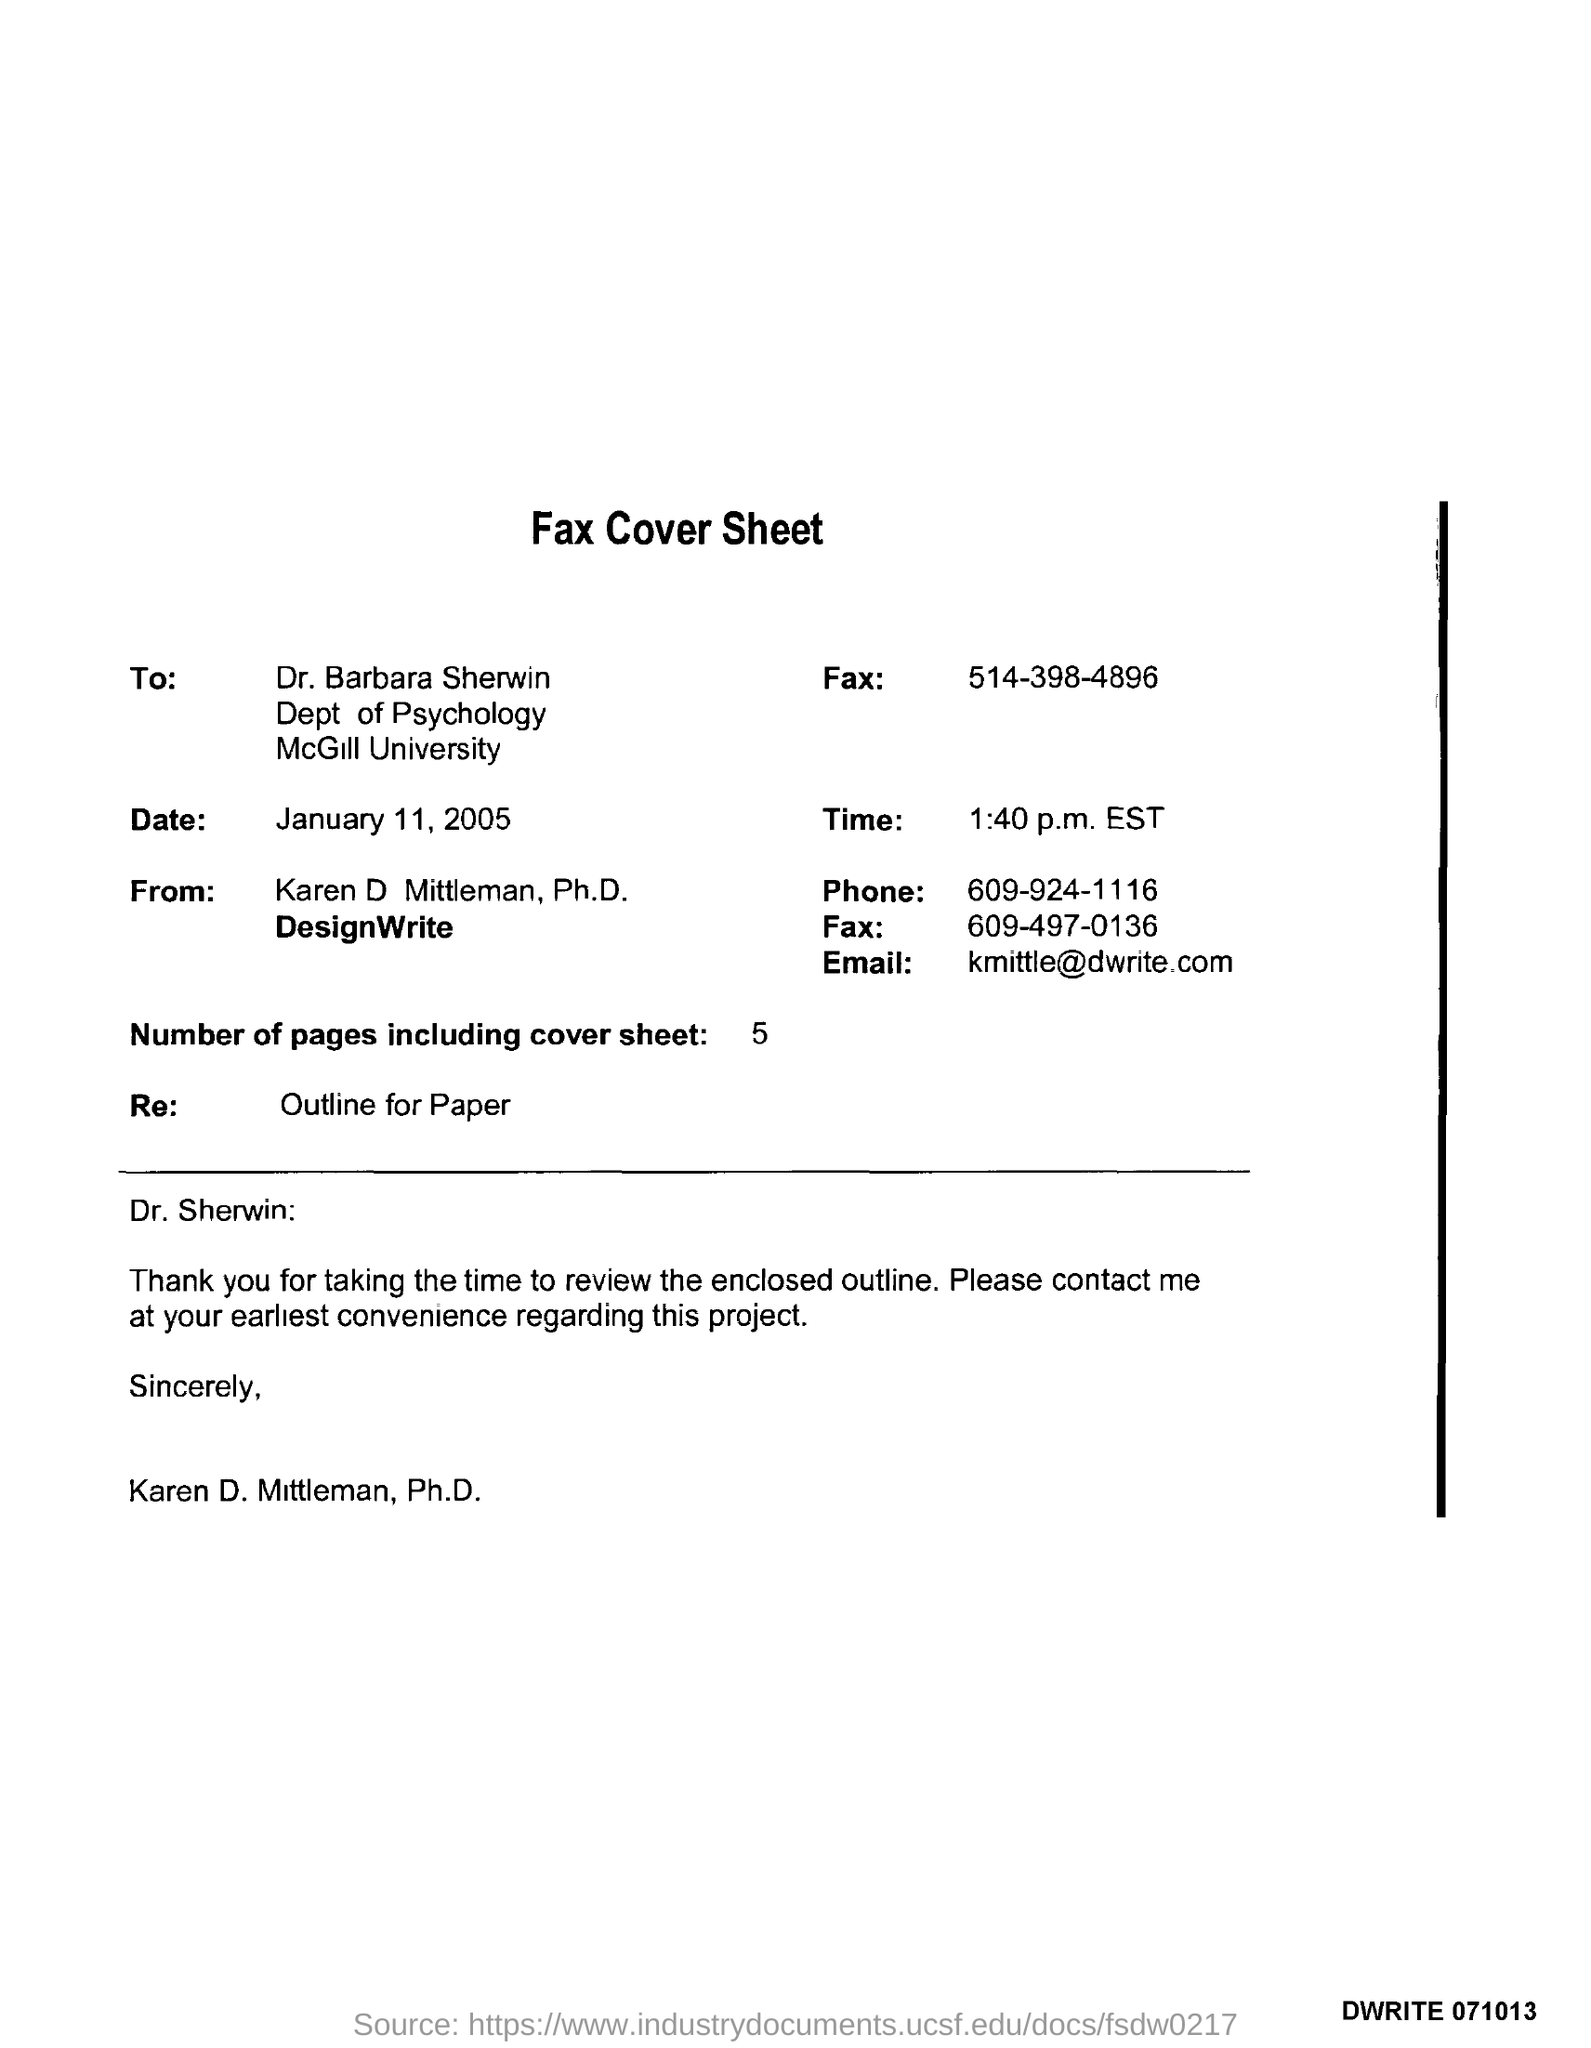Who is the receiver of the Fax?
Your response must be concise. Dr. Barbara Sherwin. In which University Dr. Barbara Sherwin works?
Your answer should be compact. McGill University. What is the  Fax No of Dr. Barbara Sherwin?
Provide a short and direct response. 514-398-4896. What is the date mentioned in the fax cover sheet?
Give a very brief answer. January 11, 2005. What is the time mentioned in fax cover sheet?
Your answer should be very brief. 1:40 p.m. EST. How many pages are there in the fax including cover sheet?
Your answer should be compact. 5. What is the Email id of Karen D Mittleman, Ph.D.?
Give a very brief answer. Kmittle@dwrite.com. 